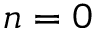Convert formula to latex. <formula><loc_0><loc_0><loc_500><loc_500>n = 0</formula> 